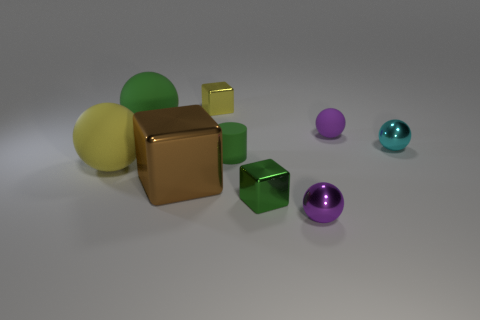There is a yellow cube that is the same size as the matte cylinder; what material is it?
Your answer should be very brief. Metal. What is the shape of the large brown shiny thing?
Make the answer very short. Cube. What is the large green sphere made of?
Your answer should be compact. Rubber. There is a tiny yellow thing that is the same material as the large brown thing; what is its shape?
Your answer should be compact. Cube. How many other things are the same shape as the tiny purple matte thing?
Ensure brevity in your answer.  4. There is a small cyan ball; how many tiny purple things are in front of it?
Provide a succinct answer. 1. Is the size of the block that is behind the tiny green matte cylinder the same as the matte sphere that is behind the small purple matte object?
Offer a very short reply. No. How many other things are the same size as the green block?
Your answer should be compact. 5. There is a big sphere in front of the metal ball that is on the right side of the small metallic thing that is in front of the green metallic cube; what is it made of?
Your answer should be very brief. Rubber. There is a purple matte sphere; is it the same size as the green thing that is behind the rubber cylinder?
Your response must be concise. No. 